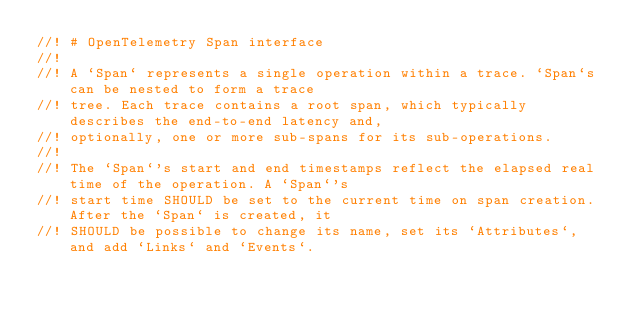Convert code to text. <code><loc_0><loc_0><loc_500><loc_500><_Rust_>//! # OpenTelemetry Span interface
//!
//! A `Span` represents a single operation within a trace. `Span`s can be nested to form a trace
//! tree. Each trace contains a root span, which typically describes the end-to-end latency and,
//! optionally, one or more sub-spans for its sub-operations.
//!
//! The `Span`'s start and end timestamps reflect the elapsed real time of the operation. A `Span`'s
//! start time SHOULD be set to the current time on span creation. After the `Span` is created, it
//! SHOULD be possible to change its name, set its `Attributes`, and add `Links` and `Events`.</code> 